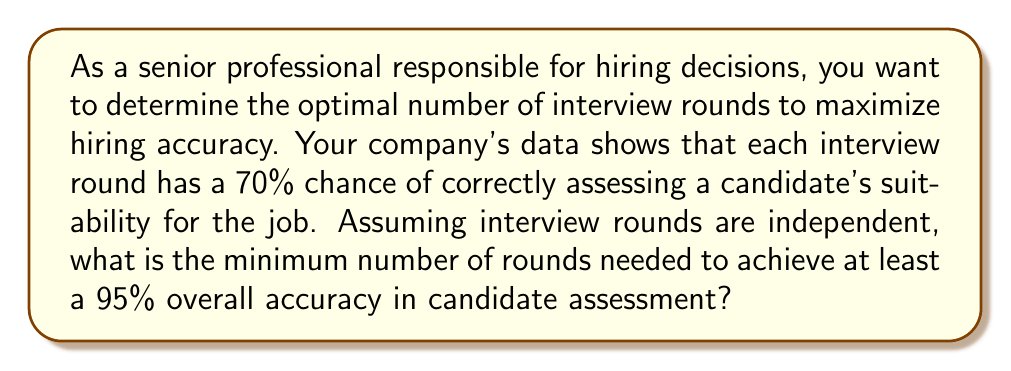Provide a solution to this math problem. Let's approach this step-by-step:

1) Let $p$ be the probability of correctly assessing a candidate in a single round. Given $p = 0.70$.

2) Let $n$ be the number of interview rounds.

3) The probability of incorrectly assessing a candidate in a single round is $1 - p = 0.30$.

4) For the overall assessment to be incorrect, all $n$ rounds must incorrectly assess the candidate. The probability of this occurring is $(1-p)^n$.

5) Therefore, the probability of correctly assessing the candidate after $n$ rounds is:

   $$1 - (1-p)^n$$

6) We want this probability to be at least 0.95:

   $$1 - (1-p)^n \geq 0.95$$

7) Solving for $n$:

   $$(1-p)^n \leq 0.05$$
   $$n \log(1-p) \leq \log(0.05)$$
   $$n \geq \frac{\log(0.05)}{\log(1-p)}$$

8) Substituting $p = 0.70$:

   $$n \geq \frac{\log(0.05)}{\log(0.30)} \approx 2.95$$

9) Since $n$ must be a whole number, we round up to the nearest integer.
Answer: The minimum number of interview rounds needed is 3. 